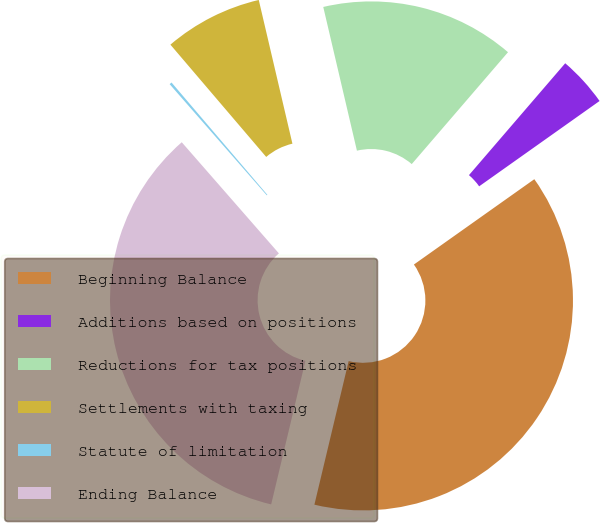Convert chart to OTSL. <chart><loc_0><loc_0><loc_500><loc_500><pie_chart><fcel>Beginning Balance<fcel>Additions based on positions<fcel>Reductions for tax positions<fcel>Settlements with taxing<fcel>Statute of limitation<fcel>Ending Balance<nl><fcel>38.54%<fcel>3.88%<fcel>14.97%<fcel>7.58%<fcel>0.19%<fcel>34.84%<nl></chart> 